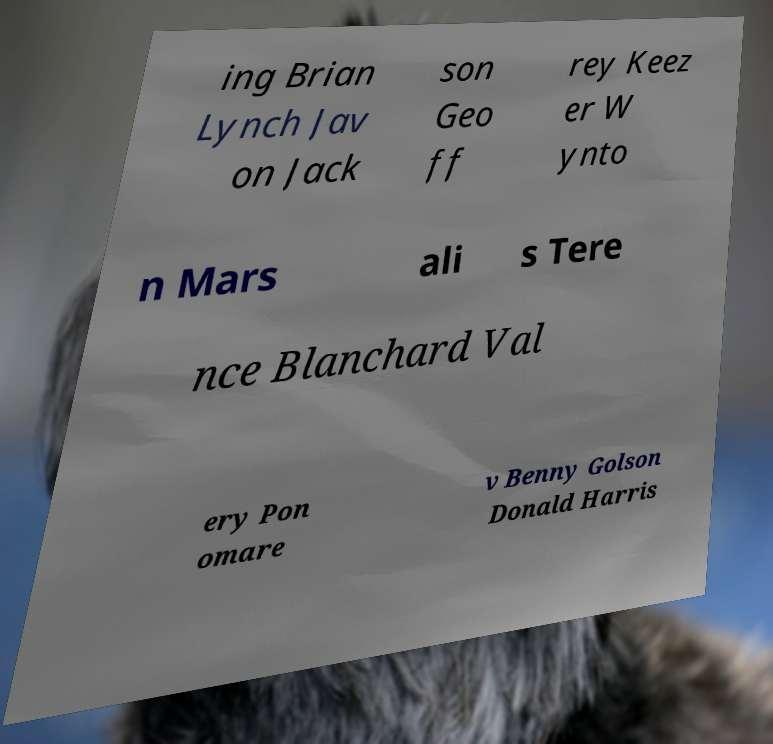Could you assist in decoding the text presented in this image and type it out clearly? ing Brian Lynch Jav on Jack son Geo ff rey Keez er W ynto n Mars ali s Tere nce Blanchard Val ery Pon omare v Benny Golson Donald Harris 